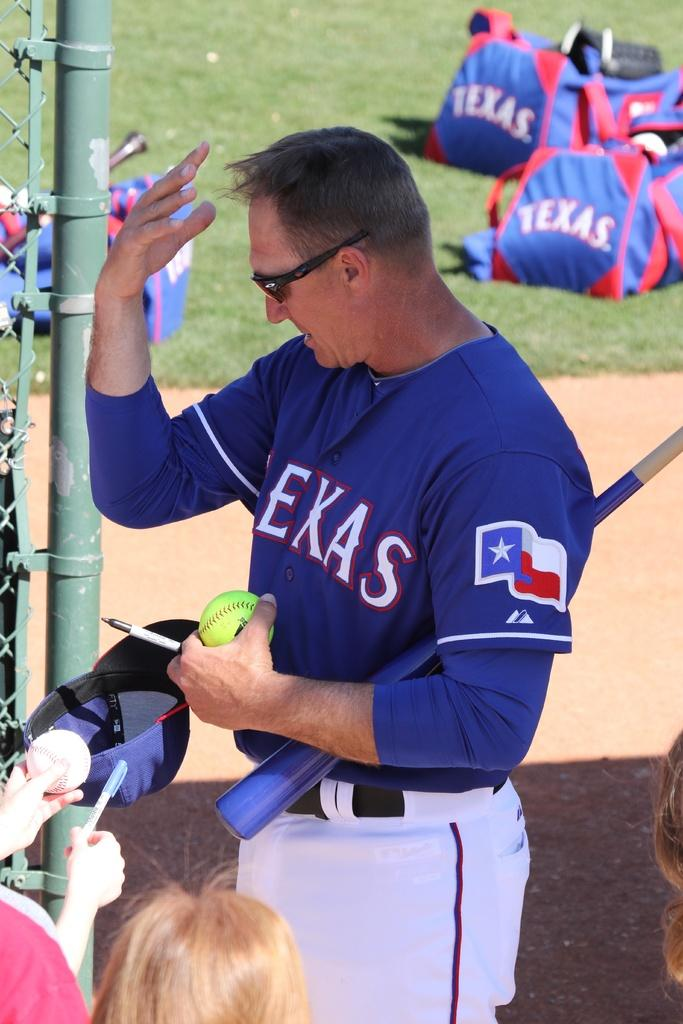<image>
Present a compact description of the photo's key features. a Texas Rangers member on a field with bags near 